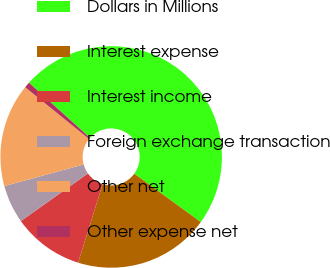Convert chart. <chart><loc_0><loc_0><loc_500><loc_500><pie_chart><fcel>Dollars in Millions<fcel>Interest expense<fcel>Interest income<fcel>Foreign exchange transaction<fcel>Other net<fcel>Other expense net<nl><fcel>48.31%<fcel>19.83%<fcel>10.34%<fcel>5.59%<fcel>15.08%<fcel>0.84%<nl></chart> 